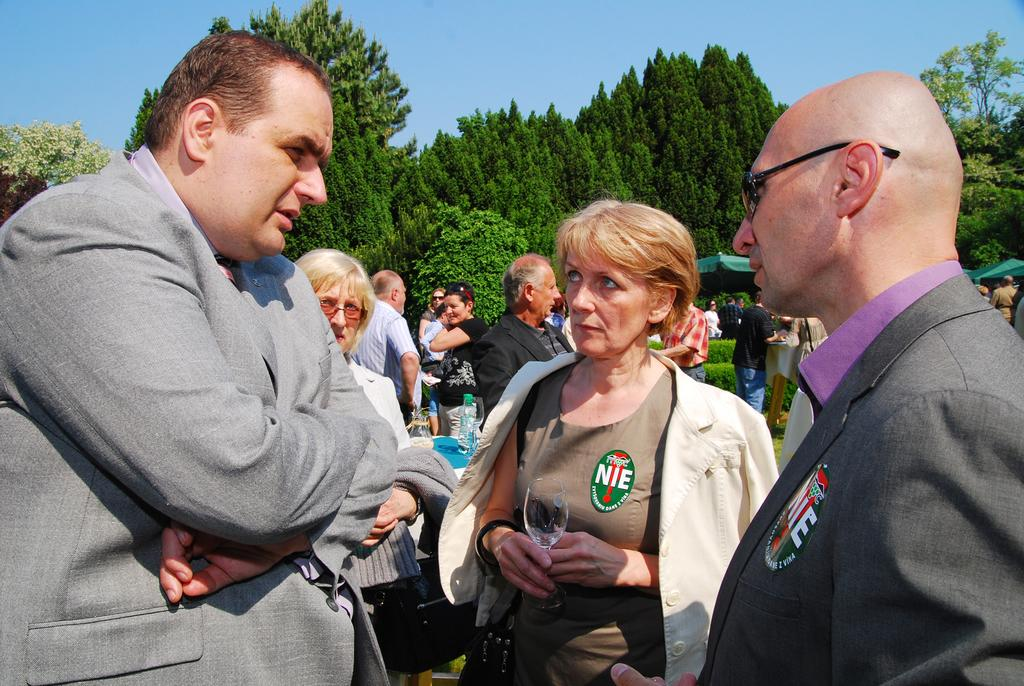What can be seen in the foreground of the picture? In the foreground of the picture, there are people, a table, a glass, and a bottle. What is located in the center of the picture? In the center of the picture, there are trees, people, plants, and tents. How is the weather depicted in the image? The sky is sunny in the image, indicating good weather. What is the value of the face on the glass in the image? There is no face on the glass in the image, and therefore no value can be assigned to it. How do the people in the center of the picture move around? The people in the center of the image are stationary, as the image is a still photograph. 